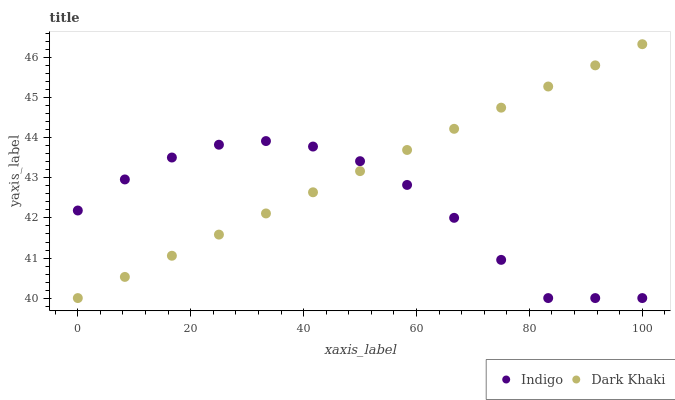Does Indigo have the minimum area under the curve?
Answer yes or no. Yes. Does Dark Khaki have the maximum area under the curve?
Answer yes or no. Yes. Does Indigo have the maximum area under the curve?
Answer yes or no. No. Is Dark Khaki the smoothest?
Answer yes or no. Yes. Is Indigo the roughest?
Answer yes or no. Yes. Is Indigo the smoothest?
Answer yes or no. No. Does Dark Khaki have the lowest value?
Answer yes or no. Yes. Does Dark Khaki have the highest value?
Answer yes or no. Yes. Does Indigo have the highest value?
Answer yes or no. No. Does Indigo intersect Dark Khaki?
Answer yes or no. Yes. Is Indigo less than Dark Khaki?
Answer yes or no. No. Is Indigo greater than Dark Khaki?
Answer yes or no. No. 